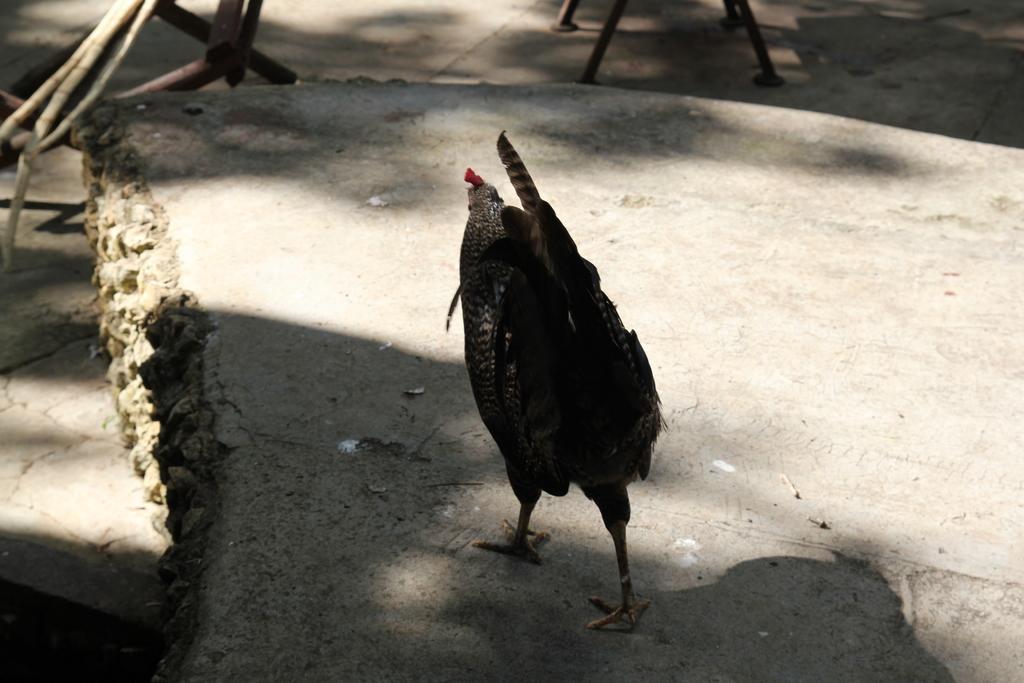Can you describe this image briefly? In this image I can see the hen which is in black and red color. It is on the concrete surface. In the background I can see the iron rods. 